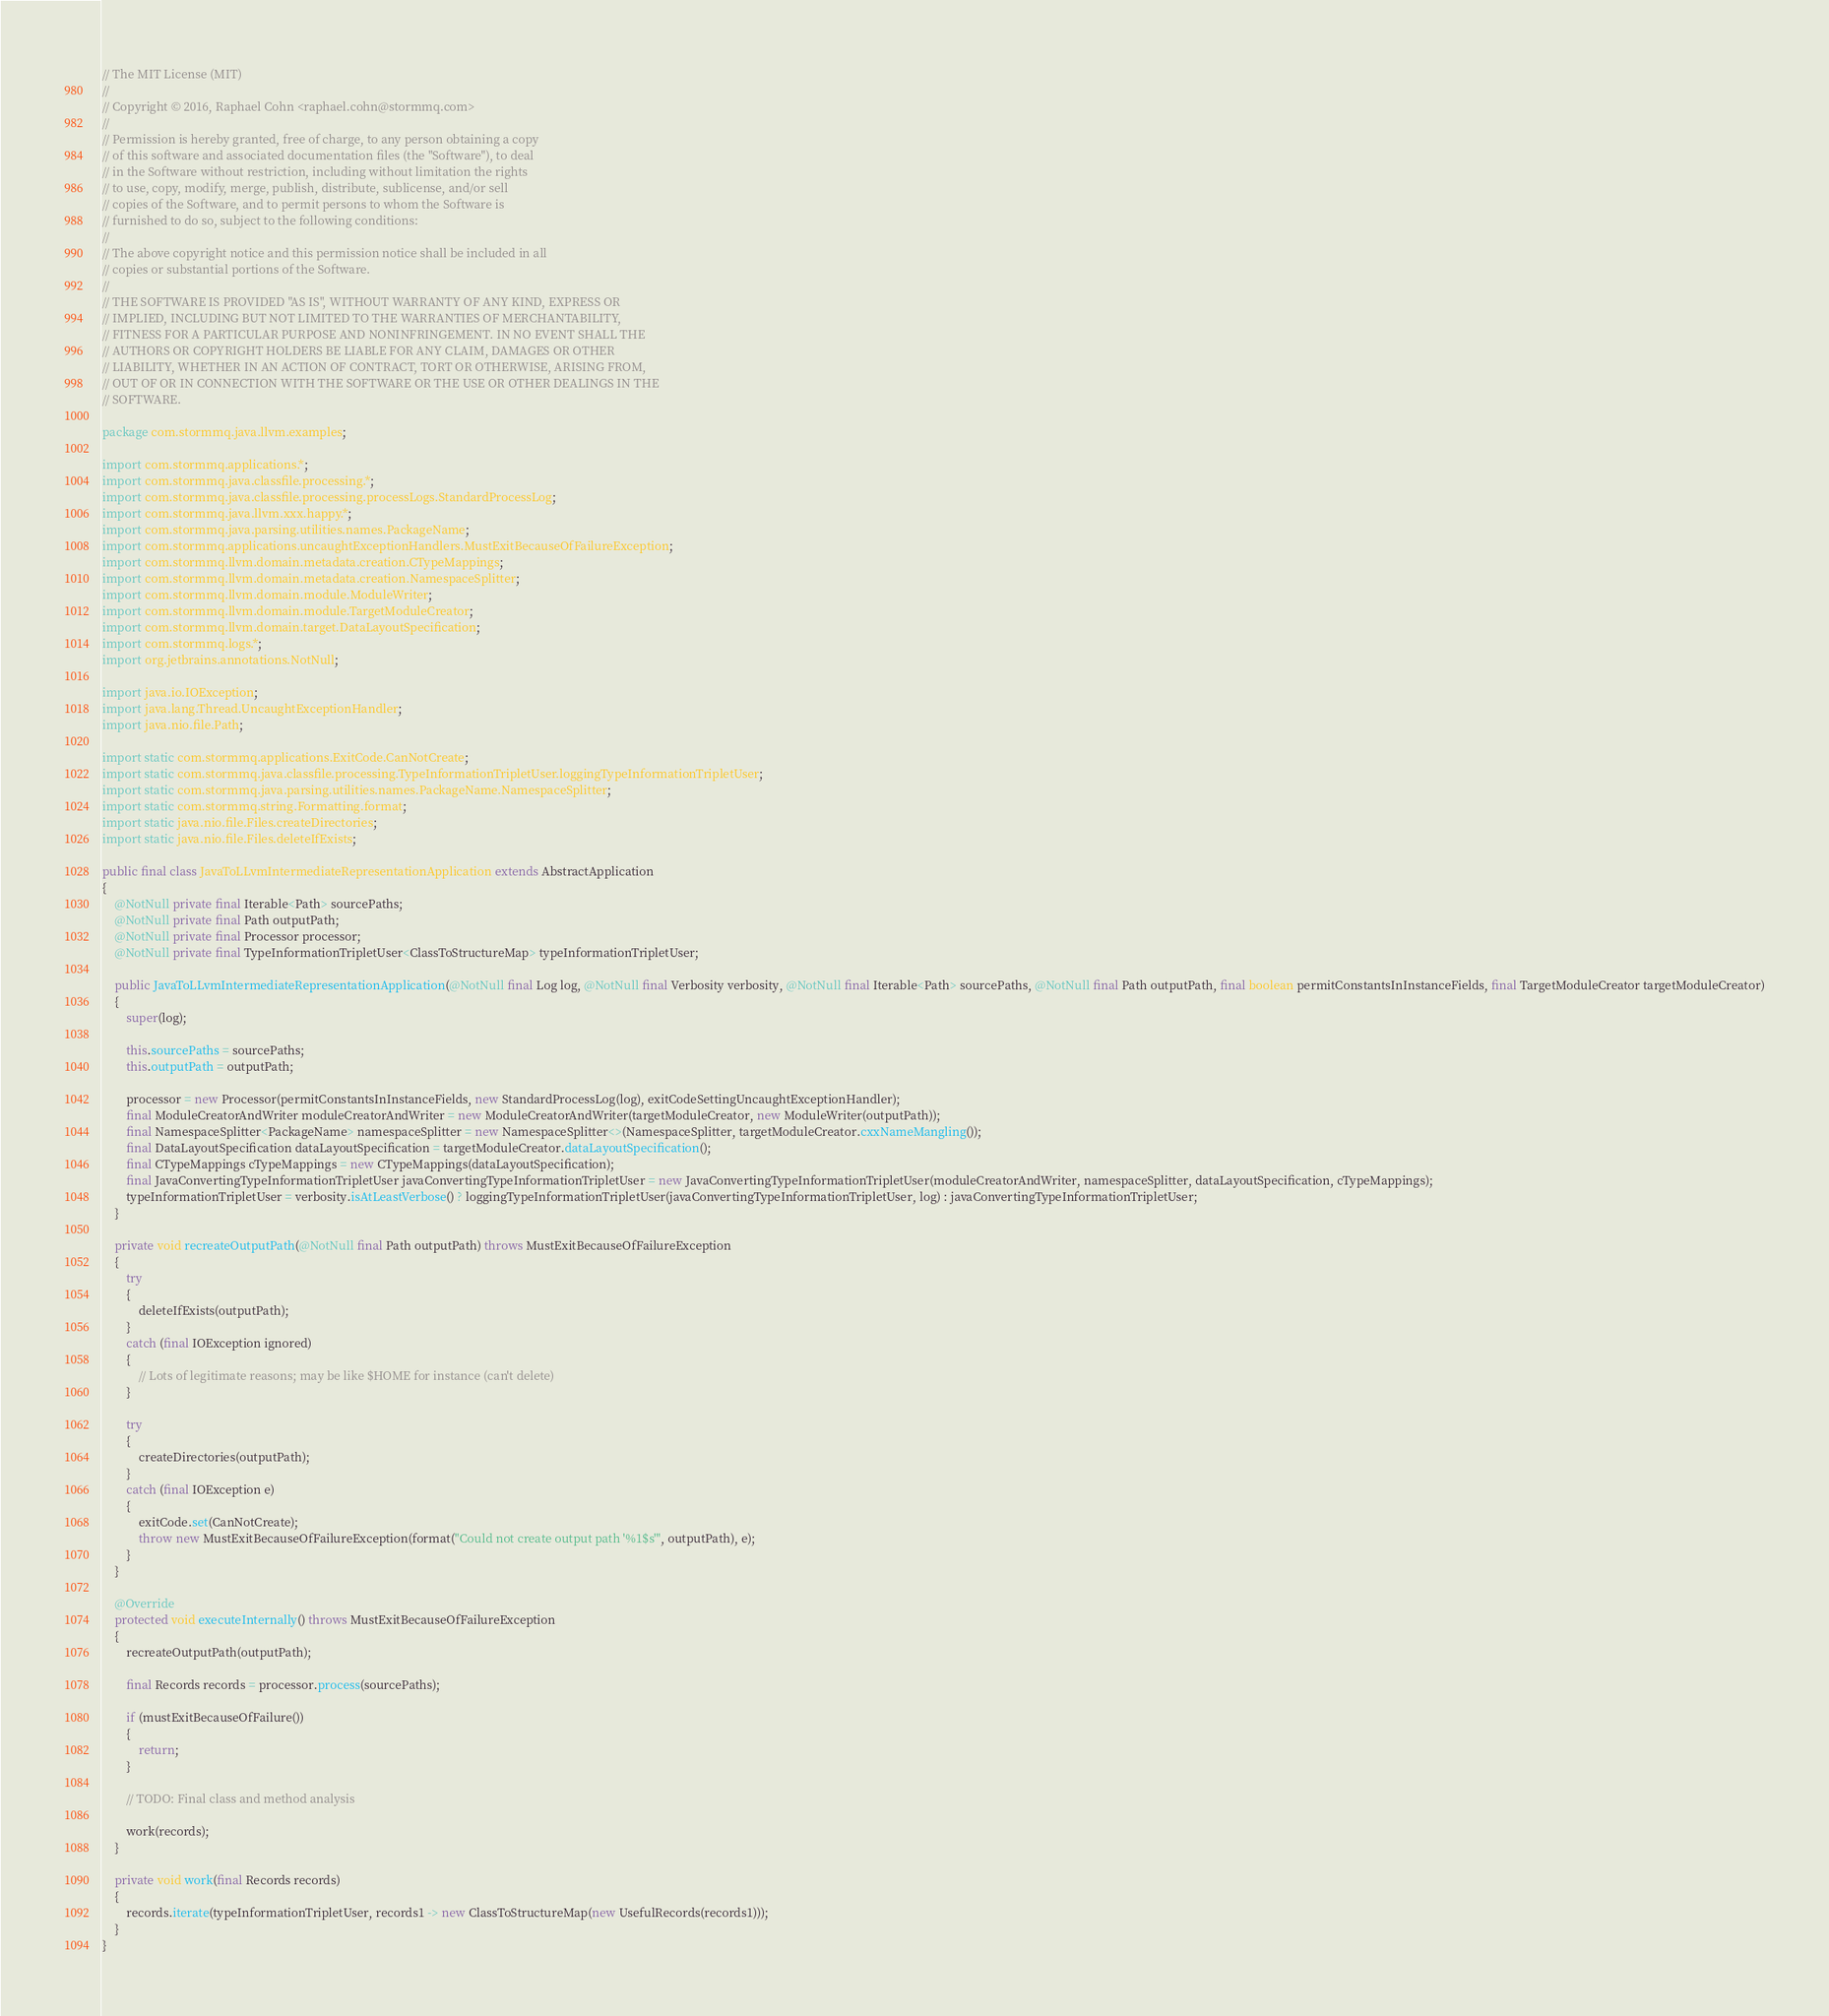<code> <loc_0><loc_0><loc_500><loc_500><_Java_>// The MIT License (MIT)
//
// Copyright © 2016, Raphael Cohn <raphael.cohn@stormmq.com>
//
// Permission is hereby granted, free of charge, to any person obtaining a copy
// of this software and associated documentation files (the "Software"), to deal
// in the Software without restriction, including without limitation the rights
// to use, copy, modify, merge, publish, distribute, sublicense, and/or sell
// copies of the Software, and to permit persons to whom the Software is
// furnished to do so, subject to the following conditions:
//
// The above copyright notice and this permission notice shall be included in all
// copies or substantial portions of the Software.
//
// THE SOFTWARE IS PROVIDED "AS IS", WITHOUT WARRANTY OF ANY KIND, EXPRESS OR
// IMPLIED, INCLUDING BUT NOT LIMITED TO THE WARRANTIES OF MERCHANTABILITY,
// FITNESS FOR A PARTICULAR PURPOSE AND NONINFRINGEMENT. IN NO EVENT SHALL THE
// AUTHORS OR COPYRIGHT HOLDERS BE LIABLE FOR ANY CLAIM, DAMAGES OR OTHER
// LIABILITY, WHETHER IN AN ACTION OF CONTRACT, TORT OR OTHERWISE, ARISING FROM,
// OUT OF OR IN CONNECTION WITH THE SOFTWARE OR THE USE OR OTHER DEALINGS IN THE
// SOFTWARE.

package com.stormmq.java.llvm.examples;

import com.stormmq.applications.*;
import com.stormmq.java.classfile.processing.*;
import com.stormmq.java.classfile.processing.processLogs.StandardProcessLog;
import com.stormmq.java.llvm.xxx.happy.*;
import com.stormmq.java.parsing.utilities.names.PackageName;
import com.stormmq.applications.uncaughtExceptionHandlers.MustExitBecauseOfFailureException;
import com.stormmq.llvm.domain.metadata.creation.CTypeMappings;
import com.stormmq.llvm.domain.metadata.creation.NamespaceSplitter;
import com.stormmq.llvm.domain.module.ModuleWriter;
import com.stormmq.llvm.domain.module.TargetModuleCreator;
import com.stormmq.llvm.domain.target.DataLayoutSpecification;
import com.stormmq.logs.*;
import org.jetbrains.annotations.NotNull;

import java.io.IOException;
import java.lang.Thread.UncaughtExceptionHandler;
import java.nio.file.Path;

import static com.stormmq.applications.ExitCode.CanNotCreate;
import static com.stormmq.java.classfile.processing.TypeInformationTripletUser.loggingTypeInformationTripletUser;
import static com.stormmq.java.parsing.utilities.names.PackageName.NamespaceSplitter;
import static com.stormmq.string.Formatting.format;
import static java.nio.file.Files.createDirectories;
import static java.nio.file.Files.deleteIfExists;

public final class JavaToLLvmIntermediateRepresentationApplication extends AbstractApplication
{
	@NotNull private final Iterable<Path> sourcePaths;
	@NotNull private final Path outputPath;
	@NotNull private final Processor processor;
	@NotNull private final TypeInformationTripletUser<ClassToStructureMap> typeInformationTripletUser;

	public JavaToLLvmIntermediateRepresentationApplication(@NotNull final Log log, @NotNull final Verbosity verbosity, @NotNull final Iterable<Path> sourcePaths, @NotNull final Path outputPath, final boolean permitConstantsInInstanceFields, final TargetModuleCreator targetModuleCreator)
	{
		super(log);

		this.sourcePaths = sourcePaths;
		this.outputPath = outputPath;

		processor = new Processor(permitConstantsInInstanceFields, new StandardProcessLog(log), exitCodeSettingUncaughtExceptionHandler);
		final ModuleCreatorAndWriter moduleCreatorAndWriter = new ModuleCreatorAndWriter(targetModuleCreator, new ModuleWriter(outputPath));
		final NamespaceSplitter<PackageName> namespaceSplitter = new NamespaceSplitter<>(NamespaceSplitter, targetModuleCreator.cxxNameMangling());
		final DataLayoutSpecification dataLayoutSpecification = targetModuleCreator.dataLayoutSpecification();
		final CTypeMappings cTypeMappings = new CTypeMappings(dataLayoutSpecification);
		final JavaConvertingTypeInformationTripletUser javaConvertingTypeInformationTripletUser = new JavaConvertingTypeInformationTripletUser(moduleCreatorAndWriter, namespaceSplitter, dataLayoutSpecification, cTypeMappings);
		typeInformationTripletUser = verbosity.isAtLeastVerbose() ? loggingTypeInformationTripletUser(javaConvertingTypeInformationTripletUser, log) : javaConvertingTypeInformationTripletUser;
	}

	private void recreateOutputPath(@NotNull final Path outputPath) throws MustExitBecauseOfFailureException
	{
		try
		{
			deleteIfExists(outputPath);
		}
		catch (final IOException ignored)
		{
			// Lots of legitimate reasons; may be like $HOME for instance (can't delete)
		}

		try
		{
			createDirectories(outputPath);
		}
		catch (final IOException e)
		{
			exitCode.set(CanNotCreate);
			throw new MustExitBecauseOfFailureException(format("Could not create output path '%1$s'", outputPath), e);
		}
	}

	@Override
	protected void executeInternally() throws MustExitBecauseOfFailureException
	{
		recreateOutputPath(outputPath);

		final Records records = processor.process(sourcePaths);

		if (mustExitBecauseOfFailure())
		{
			return;
		}

		// TODO: Final class and method analysis

		work(records);
	}

	private void work(final Records records)
	{
		records.iterate(typeInformationTripletUser, records1 -> new ClassToStructureMap(new UsefulRecords(records1)));
	}
}
</code> 